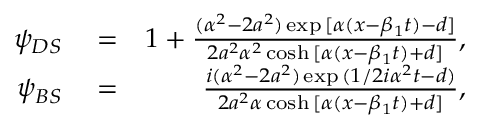<formula> <loc_0><loc_0><loc_500><loc_500>\begin{array} { r l r } { \psi _ { D S } } & = } & { 1 + \frac { ( \alpha ^ { 2 } - 2 a ^ { 2 } ) \exp { [ \alpha ( x - \beta _ { 1 } t ) - d ] } } { 2 a ^ { 2 } \alpha ^ { 2 } \cosh { [ \alpha ( x - \beta _ { 1 } t ) + d ] } } , } \\ { \psi _ { B S } } & = } & { \frac { i ( \alpha ^ { 2 } - 2 a ^ { 2 } ) \exp { ( 1 / 2 i \alpha ^ { 2 } t - d ) } } { 2 a ^ { 2 } \alpha \cosh { [ \alpha ( x - \beta _ { 1 } t ) + d ] } } , } \end{array}</formula> 